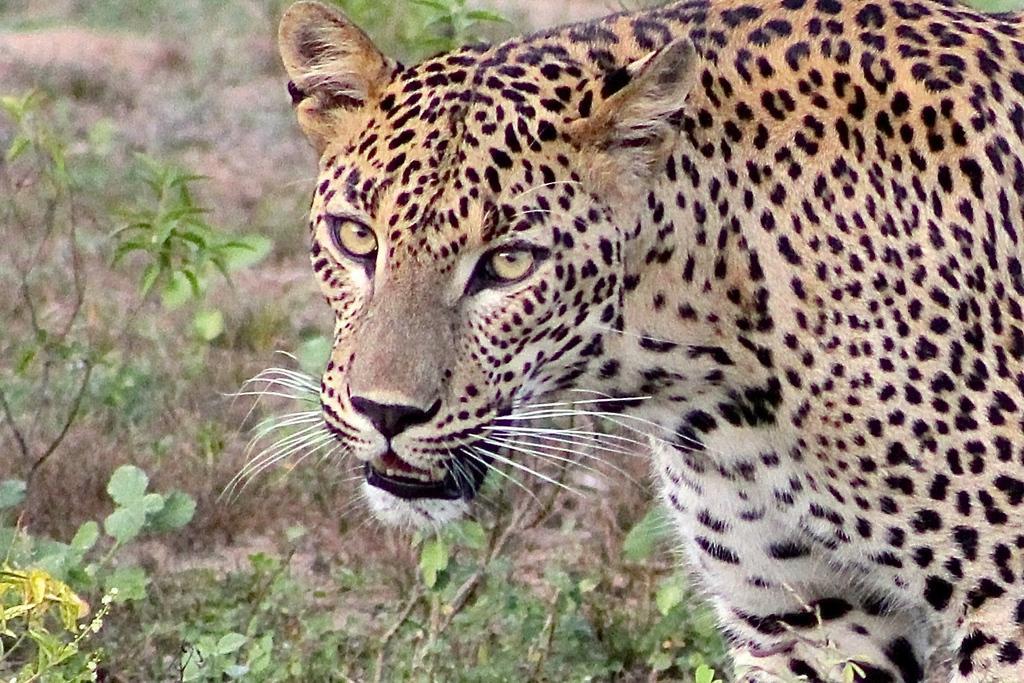Describe this image in one or two sentences. On the right side of the image we can see a cheetah. At the bottom there are plants. 